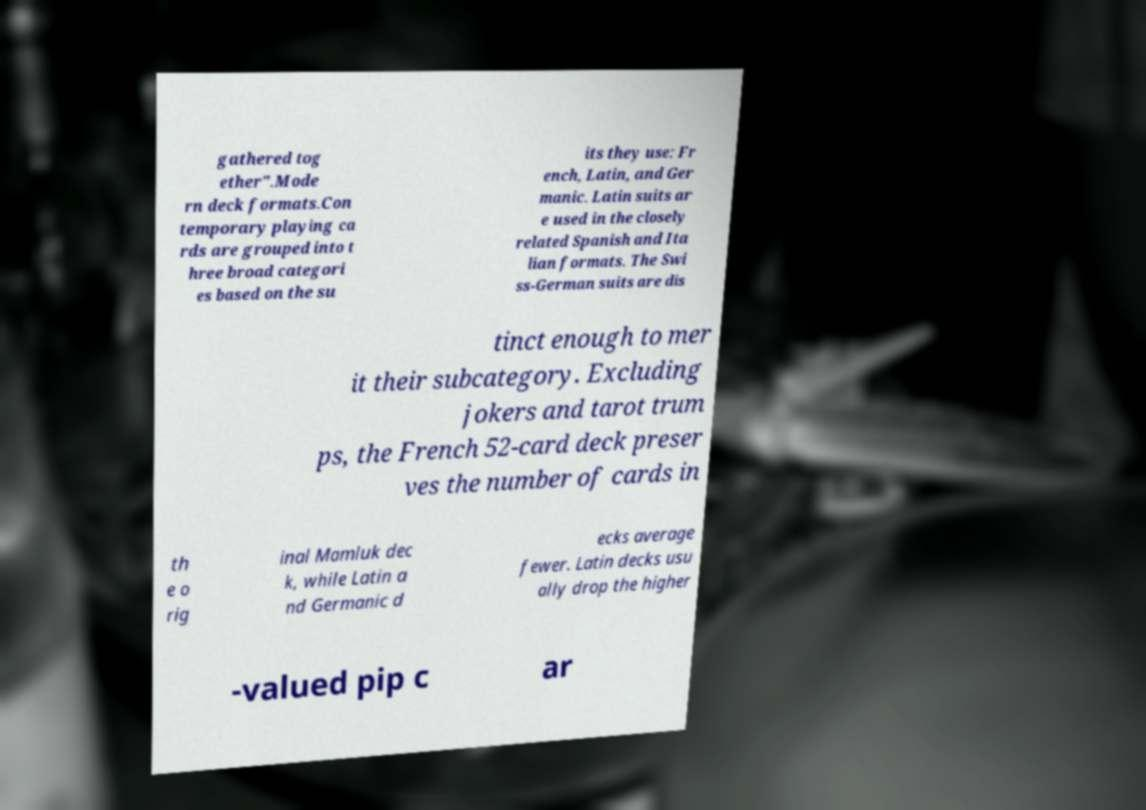Please read and relay the text visible in this image. What does it say? gathered tog ether".Mode rn deck formats.Con temporary playing ca rds are grouped into t hree broad categori es based on the su its they use: Fr ench, Latin, and Ger manic. Latin suits ar e used in the closely related Spanish and Ita lian formats. The Swi ss-German suits are dis tinct enough to mer it their subcategory. Excluding jokers and tarot trum ps, the French 52-card deck preser ves the number of cards in th e o rig inal Mamluk dec k, while Latin a nd Germanic d ecks average fewer. Latin decks usu ally drop the higher -valued pip c ar 